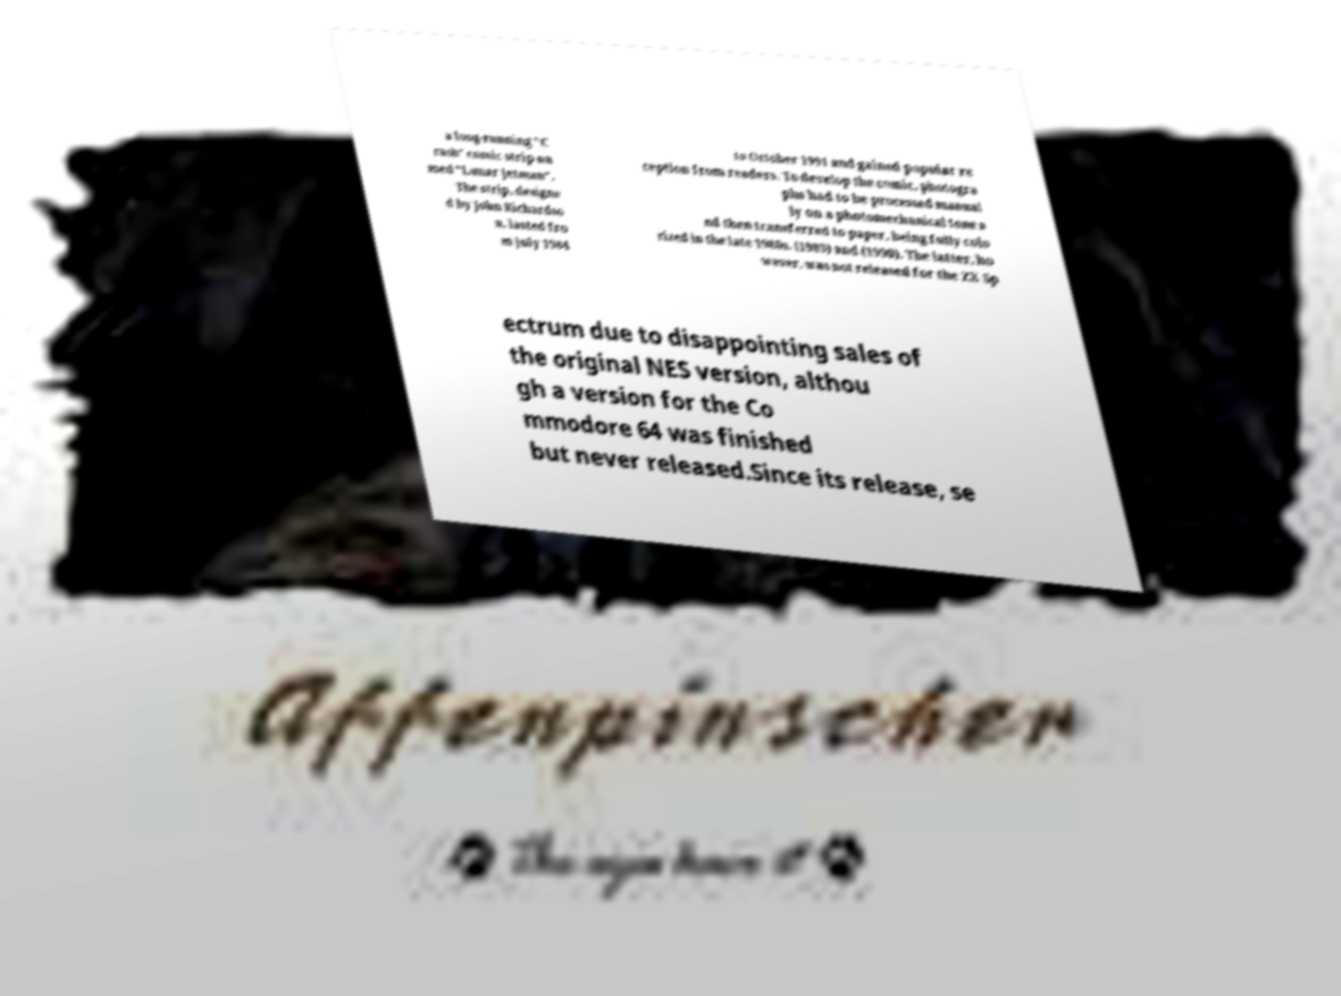Can you accurately transcribe the text from the provided image for me? a long-running "C rash" comic strip na med "Lunar Jetman". The strip, designe d by John Richardso n, lasted fro m July 1984 to October 1991 and gained popular re ception from readers. To develop the comic, photogra phs had to be processed manual ly on a photomechanical tone a nd then transferred to paper, being fully colo rized in the late 1980s. (1983) and (1990). The latter, ho wever, was not released for the ZX Sp ectrum due to disappointing sales of the original NES version, althou gh a version for the Co mmodore 64 was finished but never released.Since its release, se 